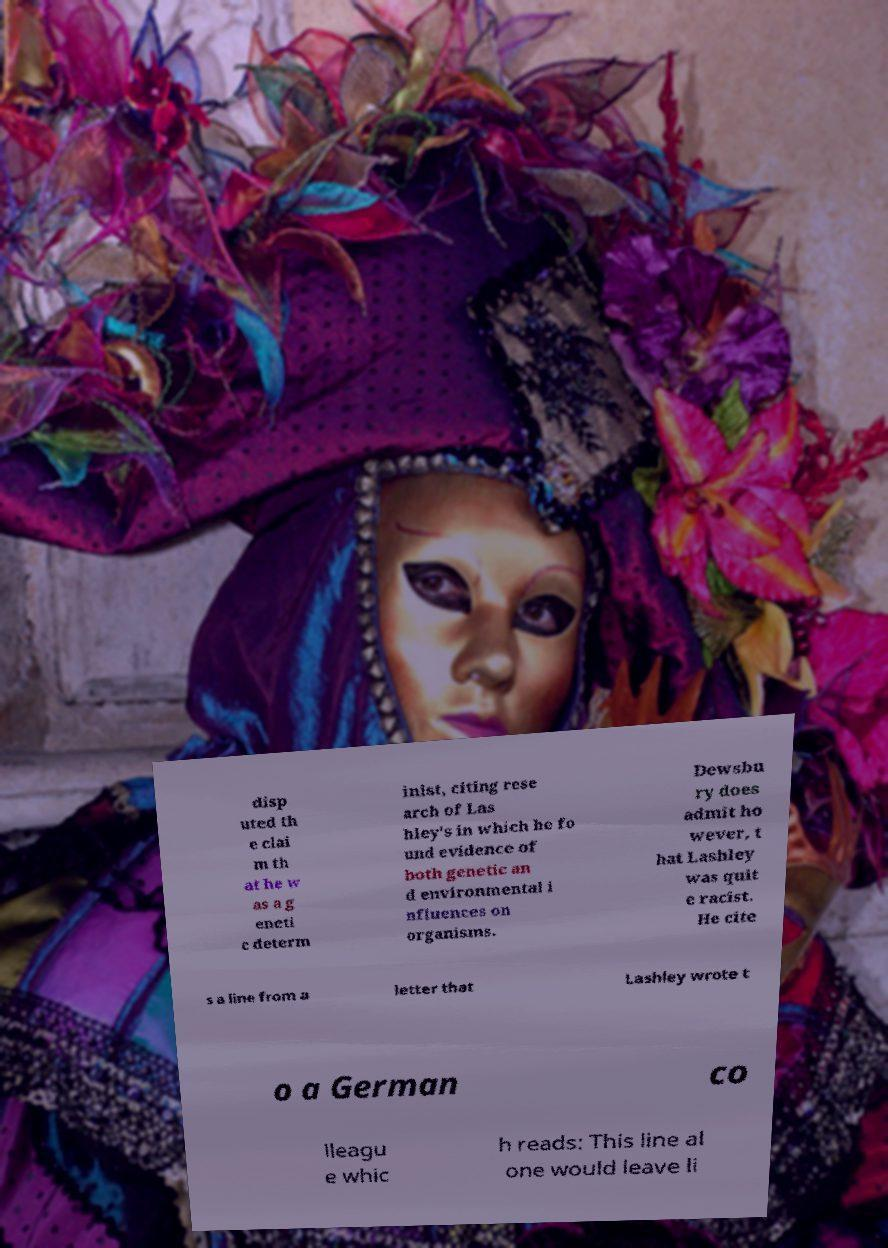Can you read and provide the text displayed in the image?This photo seems to have some interesting text. Can you extract and type it out for me? disp uted th e clai m th at he w as a g eneti c determ inist, citing rese arch of Las hley's in which he fo und evidence of both genetic an d environmental i nfluences on organisms. Dewsbu ry does admit ho wever, t hat Lashley was quit e racist. He cite s a line from a letter that Lashley wrote t o a German co lleagu e whic h reads: This line al one would leave li 